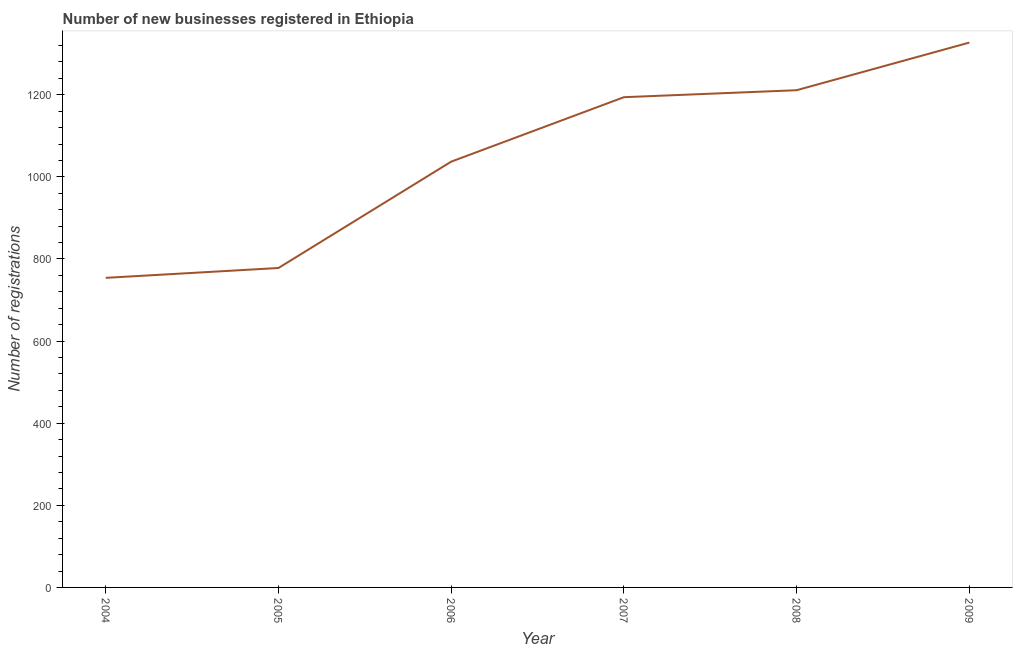What is the number of new business registrations in 2004?
Give a very brief answer. 754. Across all years, what is the maximum number of new business registrations?
Provide a short and direct response. 1327. Across all years, what is the minimum number of new business registrations?
Make the answer very short. 754. In which year was the number of new business registrations maximum?
Keep it short and to the point. 2009. In which year was the number of new business registrations minimum?
Make the answer very short. 2004. What is the sum of the number of new business registrations?
Your answer should be very brief. 6301. What is the difference between the number of new business registrations in 2005 and 2006?
Give a very brief answer. -259. What is the average number of new business registrations per year?
Keep it short and to the point. 1050.17. What is the median number of new business registrations?
Give a very brief answer. 1115.5. What is the ratio of the number of new business registrations in 2004 to that in 2009?
Ensure brevity in your answer.  0.57. Is the number of new business registrations in 2004 less than that in 2007?
Your response must be concise. Yes. What is the difference between the highest and the second highest number of new business registrations?
Ensure brevity in your answer.  116. Is the sum of the number of new business registrations in 2004 and 2009 greater than the maximum number of new business registrations across all years?
Your answer should be compact. Yes. What is the difference between the highest and the lowest number of new business registrations?
Provide a succinct answer. 573. In how many years, is the number of new business registrations greater than the average number of new business registrations taken over all years?
Offer a very short reply. 3. Does the number of new business registrations monotonically increase over the years?
Provide a short and direct response. Yes. How many lines are there?
Keep it short and to the point. 1. What is the difference between two consecutive major ticks on the Y-axis?
Keep it short and to the point. 200. Are the values on the major ticks of Y-axis written in scientific E-notation?
Ensure brevity in your answer.  No. What is the title of the graph?
Keep it short and to the point. Number of new businesses registered in Ethiopia. What is the label or title of the X-axis?
Offer a very short reply. Year. What is the label or title of the Y-axis?
Keep it short and to the point. Number of registrations. What is the Number of registrations of 2004?
Provide a succinct answer. 754. What is the Number of registrations in 2005?
Your answer should be compact. 778. What is the Number of registrations in 2006?
Offer a terse response. 1037. What is the Number of registrations of 2007?
Your response must be concise. 1194. What is the Number of registrations in 2008?
Your response must be concise. 1211. What is the Number of registrations of 2009?
Your answer should be compact. 1327. What is the difference between the Number of registrations in 2004 and 2005?
Keep it short and to the point. -24. What is the difference between the Number of registrations in 2004 and 2006?
Your response must be concise. -283. What is the difference between the Number of registrations in 2004 and 2007?
Make the answer very short. -440. What is the difference between the Number of registrations in 2004 and 2008?
Offer a terse response. -457. What is the difference between the Number of registrations in 2004 and 2009?
Offer a very short reply. -573. What is the difference between the Number of registrations in 2005 and 2006?
Offer a very short reply. -259. What is the difference between the Number of registrations in 2005 and 2007?
Ensure brevity in your answer.  -416. What is the difference between the Number of registrations in 2005 and 2008?
Your answer should be compact. -433. What is the difference between the Number of registrations in 2005 and 2009?
Your answer should be compact. -549. What is the difference between the Number of registrations in 2006 and 2007?
Offer a terse response. -157. What is the difference between the Number of registrations in 2006 and 2008?
Your answer should be compact. -174. What is the difference between the Number of registrations in 2006 and 2009?
Offer a very short reply. -290. What is the difference between the Number of registrations in 2007 and 2008?
Your answer should be very brief. -17. What is the difference between the Number of registrations in 2007 and 2009?
Your response must be concise. -133. What is the difference between the Number of registrations in 2008 and 2009?
Your answer should be compact. -116. What is the ratio of the Number of registrations in 2004 to that in 2005?
Ensure brevity in your answer.  0.97. What is the ratio of the Number of registrations in 2004 to that in 2006?
Keep it short and to the point. 0.73. What is the ratio of the Number of registrations in 2004 to that in 2007?
Give a very brief answer. 0.63. What is the ratio of the Number of registrations in 2004 to that in 2008?
Provide a short and direct response. 0.62. What is the ratio of the Number of registrations in 2004 to that in 2009?
Keep it short and to the point. 0.57. What is the ratio of the Number of registrations in 2005 to that in 2007?
Ensure brevity in your answer.  0.65. What is the ratio of the Number of registrations in 2005 to that in 2008?
Make the answer very short. 0.64. What is the ratio of the Number of registrations in 2005 to that in 2009?
Your response must be concise. 0.59. What is the ratio of the Number of registrations in 2006 to that in 2007?
Provide a succinct answer. 0.87. What is the ratio of the Number of registrations in 2006 to that in 2008?
Your response must be concise. 0.86. What is the ratio of the Number of registrations in 2006 to that in 2009?
Make the answer very short. 0.78. What is the ratio of the Number of registrations in 2007 to that in 2009?
Provide a succinct answer. 0.9. 